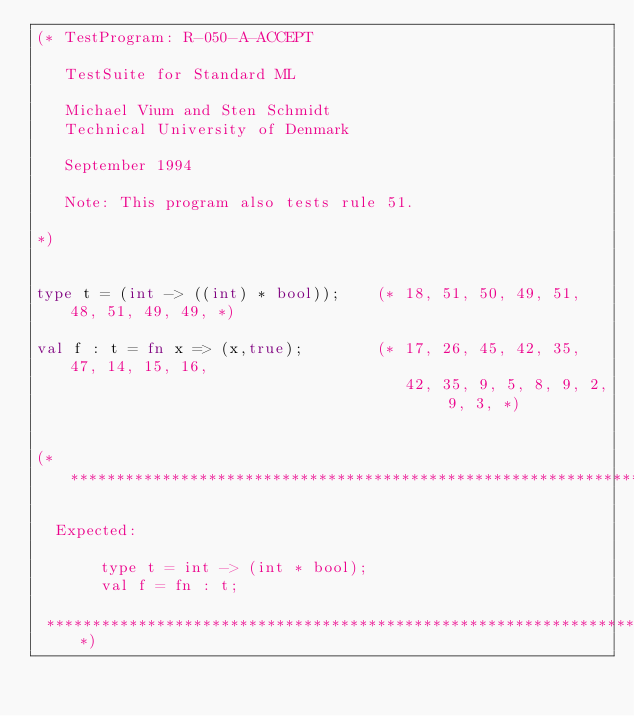<code> <loc_0><loc_0><loc_500><loc_500><_SML_>(* TestProgram: R-050-A-ACCEPT

   TestSuite for Standard ML

   Michael Vium and Sten Schmidt
   Technical University of Denmark

   September 1994

   Note: This program also tests rule 51.

*)


type t = (int -> ((int) * bool));    (* 18, 51, 50, 49, 51, 48, 51, 49, 49, *)

val f : t = fn x => (x,true);        (* 17, 26, 45, 42, 35, 47, 14, 15, 16,
                                        42, 35, 9, 5, 8, 9, 2, 9, 3, *)


(******************************************************************************

  Expected:

       type t = int -> (int * bool);
       val f = fn : t;

 ******************************************************************************)


</code> 